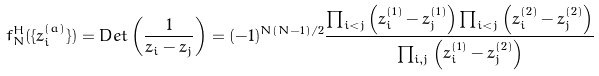Convert formula to latex. <formula><loc_0><loc_0><loc_500><loc_500>f _ { N } ^ { H } ( \{ z _ { i } ^ { ( a ) } \} ) = D e t \left ( \frac { 1 } { z _ { i } - z _ { j } } \right ) = ( - 1 ) ^ { N ( N - 1 ) / 2 } \frac { \prod _ { i < j } \left ( z _ { i } ^ { ( 1 ) } - z _ { j } ^ { ( 1 ) } \right ) \prod _ { i < j } \left ( z _ { i } ^ { ( 2 ) } - z _ { j } ^ { ( 2 ) } \right ) } { \prod _ { i , j } \left ( z _ { i } ^ { ( 1 ) } - z _ { j } ^ { ( 2 ) } \right ) }</formula> 